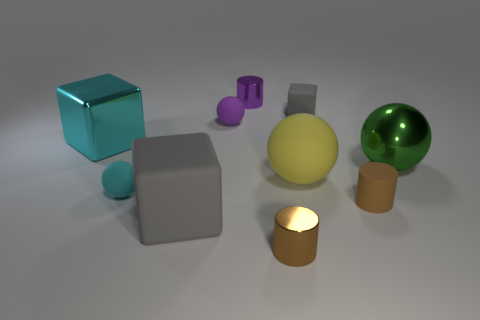What is the material of the small purple thing that is behind the rubber cube behind the big green ball?
Provide a short and direct response. Metal. There is a big green thing that is the same shape as the cyan rubber object; what is its material?
Provide a succinct answer. Metal. There is a small metallic cylinder that is in front of the large thing that is in front of the matte cylinder; are there any metallic objects that are to the right of it?
Keep it short and to the point. Yes. How many other objects are the same color as the rubber cylinder?
Ensure brevity in your answer.  1. What number of blocks are both left of the small brown metal cylinder and behind the big green ball?
Keep it short and to the point. 1. There is a small brown metallic object; what shape is it?
Keep it short and to the point. Cylinder. How many other things are there of the same material as the large green object?
Your response must be concise. 3. What color is the matte block that is to the left of the big rubber object on the right side of the purple rubber ball that is behind the small brown metal thing?
Offer a very short reply. Gray. There is a cube that is the same size as the purple shiny thing; what is it made of?
Your response must be concise. Rubber. How many objects are metallic cylinders that are in front of the small matte cube or small brown shiny blocks?
Ensure brevity in your answer.  1. 